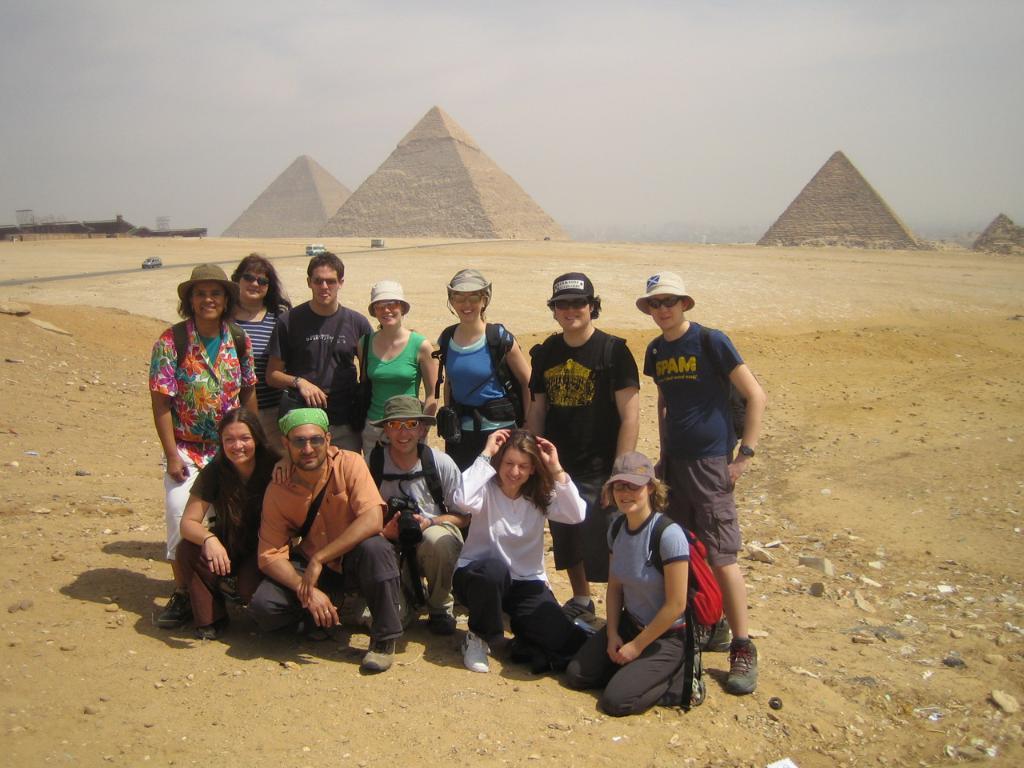Could you give a brief overview of what you see in this image? In the center of the image we can see a few people are in different costumes and they are smiling. Among them, we can see a few people are wearing caps and a few people are wearing glasses. In the background, we can see the sky, clouds, pyramids and a few other objects. 